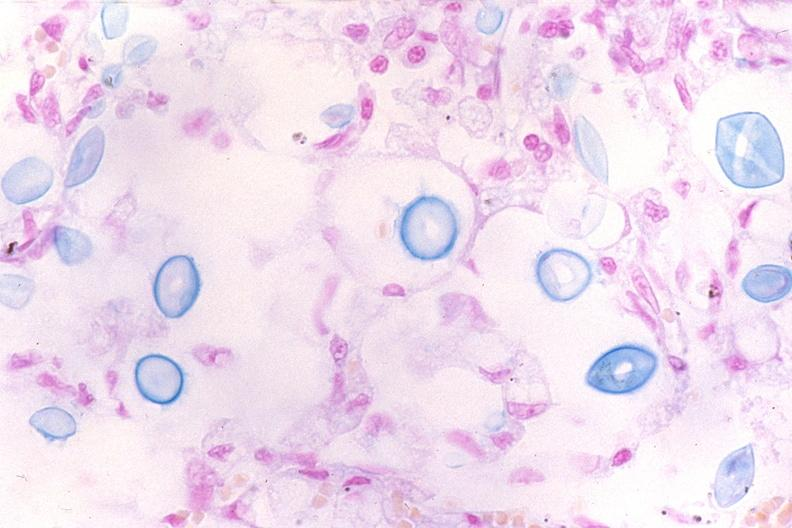where is this?
Answer the question using a single word or phrase. Lung 